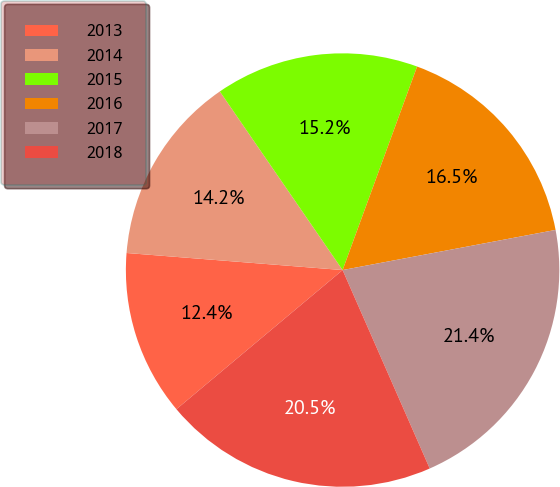Convert chart to OTSL. <chart><loc_0><loc_0><loc_500><loc_500><pie_chart><fcel>2013<fcel>2014<fcel>2015<fcel>2016<fcel>2017<fcel>2018<nl><fcel>12.35%<fcel>14.16%<fcel>15.17%<fcel>16.45%<fcel>21.38%<fcel>20.49%<nl></chart> 